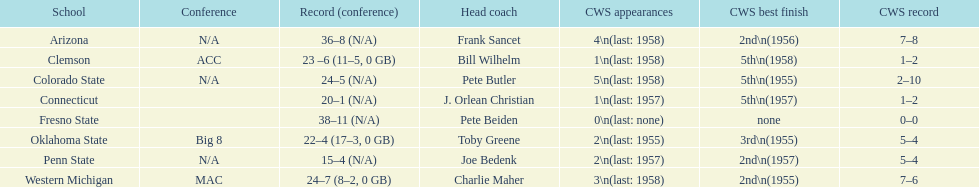What are the number of schools with more than 2 cws appearances? 3. 